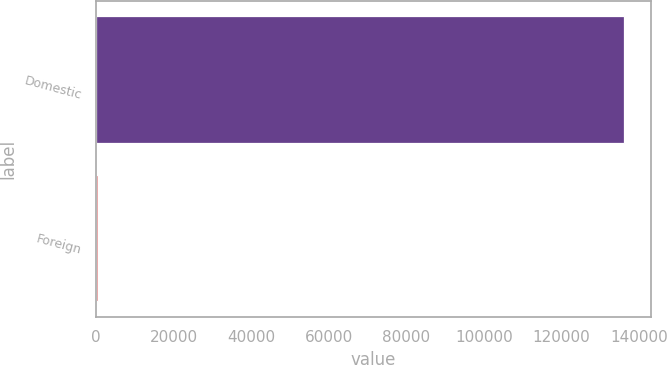Convert chart to OTSL. <chart><loc_0><loc_0><loc_500><loc_500><bar_chart><fcel>Domestic<fcel>Foreign<nl><fcel>136239<fcel>386<nl></chart> 